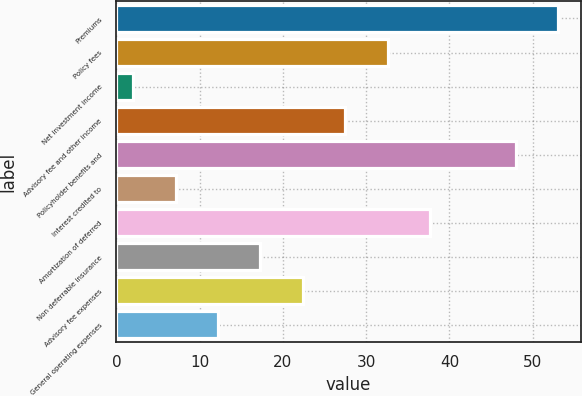<chart> <loc_0><loc_0><loc_500><loc_500><bar_chart><fcel>Premiums<fcel>Policy fees<fcel>Net investment income<fcel>Advisory fee and other income<fcel>Policyholder benefits and<fcel>Interest credited to<fcel>Amortization of deferred<fcel>Non deferrable insurance<fcel>Advisory fee expenses<fcel>General operating expenses<nl><fcel>53.1<fcel>32.6<fcel>2<fcel>27.5<fcel>48<fcel>7.1<fcel>37.7<fcel>17.3<fcel>22.4<fcel>12.2<nl></chart> 